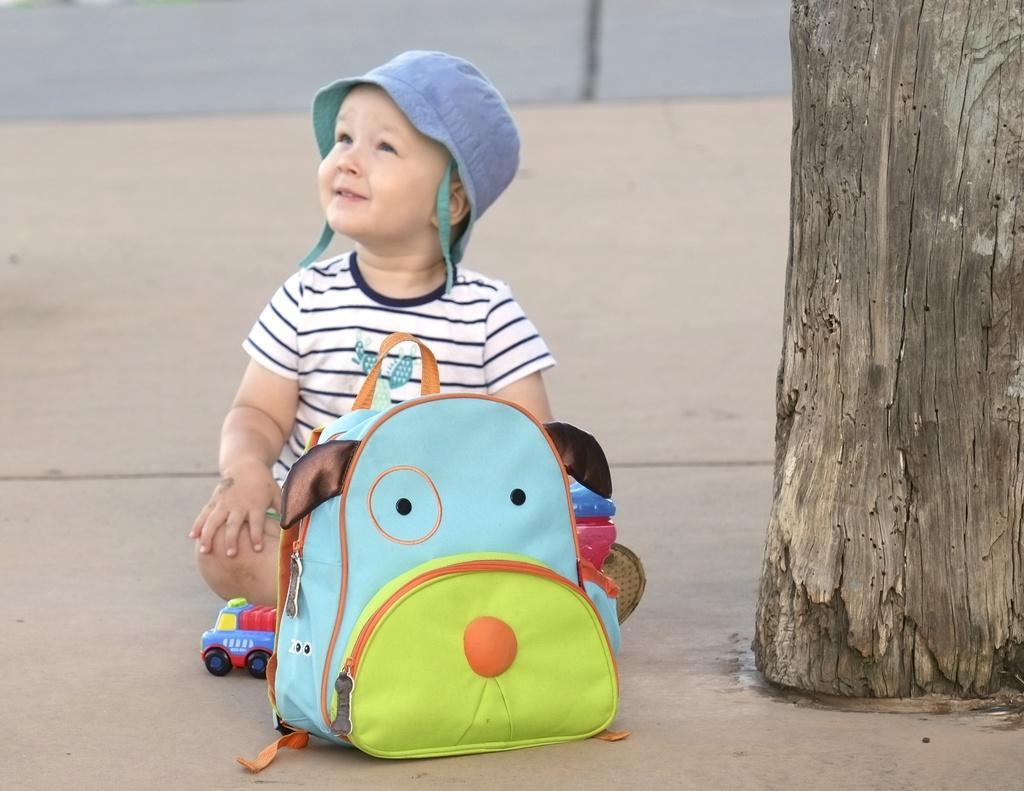Could you give a brief overview of what you see in this image? This picture consists of a boy sitting in the center on the floor. In the front of the boy there is a bag and the toy. At the right side there is a tree. In the background there is a road. The boy is wearing a grey colour hat. 